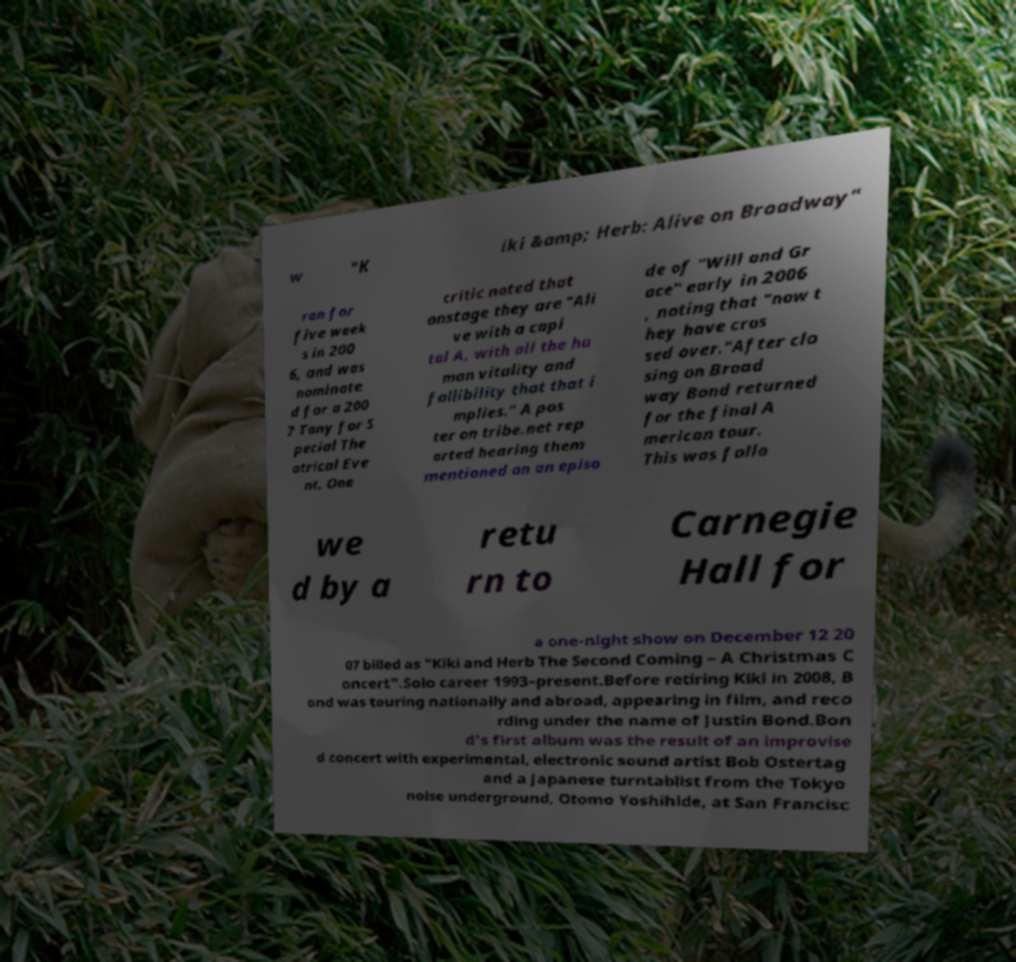Could you assist in decoding the text presented in this image and type it out clearly? w "K iki &amp; Herb: Alive on Broadway" ran for five week s in 200 6, and was nominate d for a 200 7 Tony for S pecial The atrical Eve nt. One critic noted that onstage they are "Ali ve with a capi tal A, with all the hu man vitality and fallibility that that i mplies." A pos ter on tribe.net rep orted hearing them mentioned on an episo de of "Will and Gr ace" early in 2006 , noting that "now t hey have cros sed over."After clo sing on Broad way Bond returned for the final A merican tour. This was follo we d by a retu rn to Carnegie Hall for a one-night show on December 12 20 07 billed as "Kiki and Herb The Second Coming – A Christmas C oncert".Solo career 1993–present.Before retiring Kiki in 2008, B ond was touring nationally and abroad, appearing in film, and reco rding under the name of Justin Bond.Bon d's first album was the result of an improvise d concert with experimental, electronic sound artist Bob Ostertag and a Japanese turntablist from the Tokyo noise underground, Otomo Yoshihide, at San Francisc 